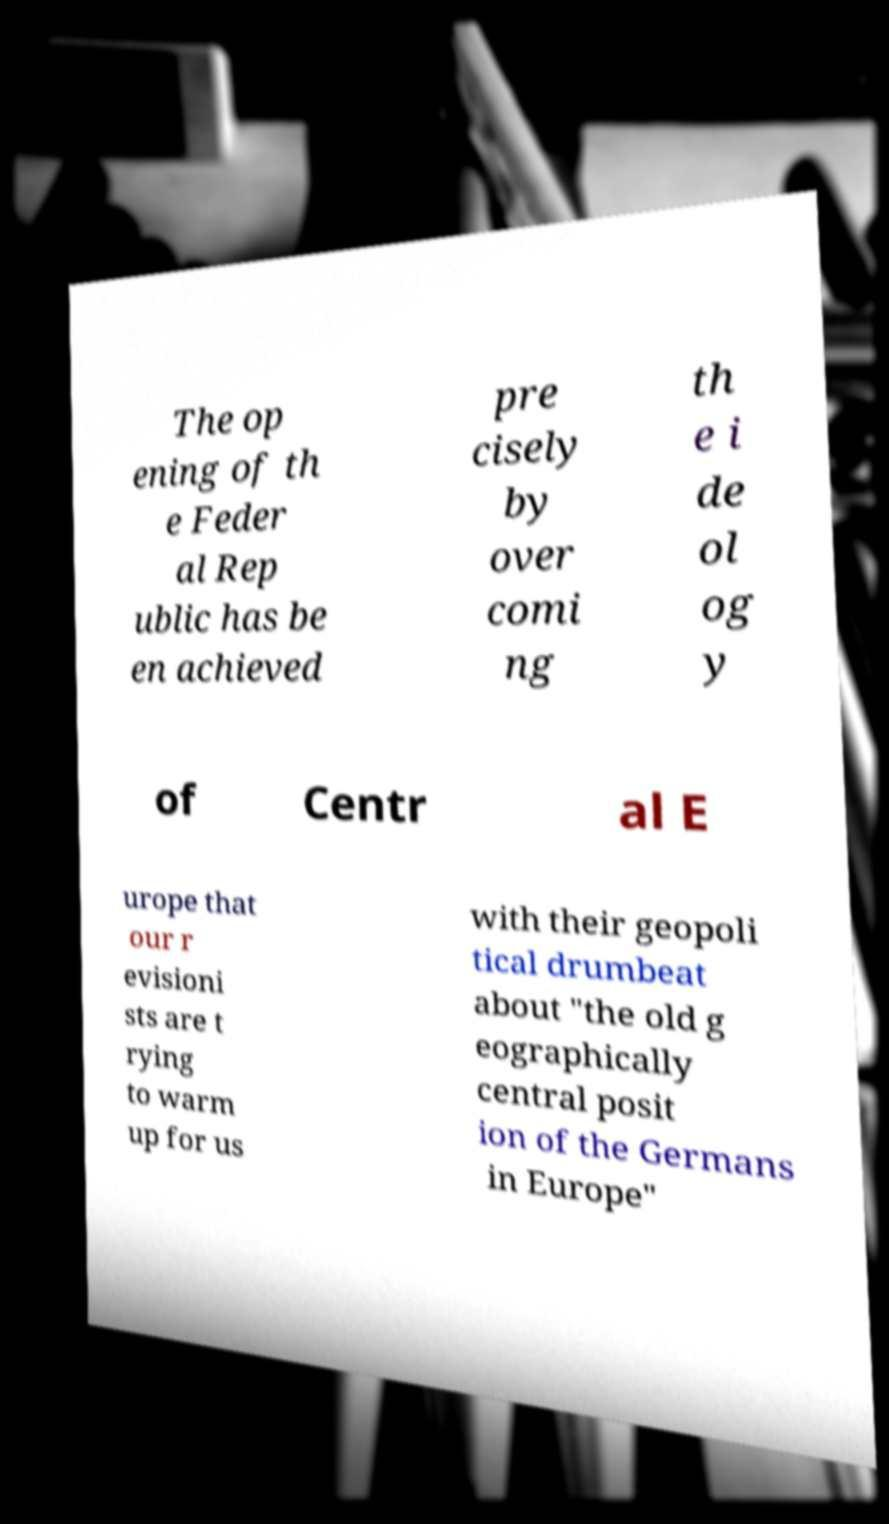Can you accurately transcribe the text from the provided image for me? The op ening of th e Feder al Rep ublic has be en achieved pre cisely by over comi ng th e i de ol og y of Centr al E urope that our r evisioni sts are t rying to warm up for us with their geopoli tical drumbeat about "the old g eographically central posit ion of the Germans in Europe" 